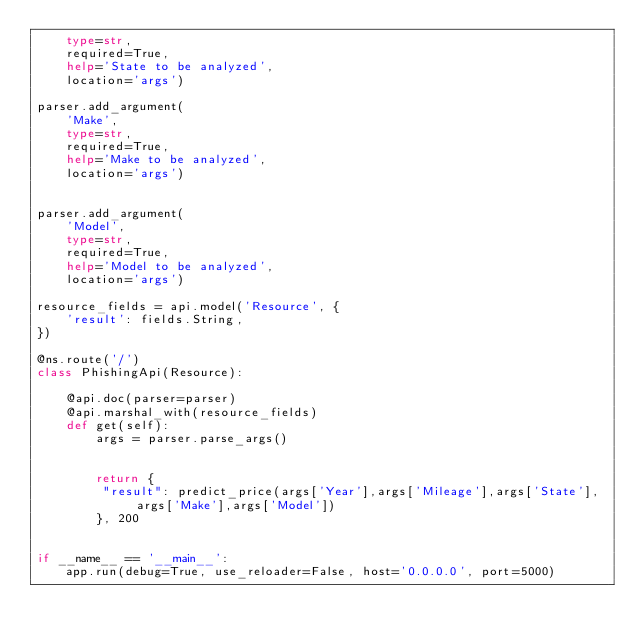Convert code to text. <code><loc_0><loc_0><loc_500><loc_500><_Python_>    type=str, 
    required=True, 
    help='State to be analyzed', 
    location='args')

parser.add_argument(
    'Make', 
    type=str, 
    required=True, 
    help='Make to be analyzed', 
    location='args')


parser.add_argument(
    'Model', 
    type=str, 
    required=True, 
    help='Model to be analyzed', 
    location='args')

resource_fields = api.model('Resource', {
    'result': fields.String,
})

@ns.route('/')
class PhishingApi(Resource):

    @api.doc(parser=parser)
    @api.marshal_with(resource_fields)
    def get(self):
        args = parser.parse_args()
        
                
        return {
         "result": predict_price(args['Year'],args['Mileage'],args['State'],args['Make'],args['Model'])
        }, 200
    
    
if __name__ == '__main__':
    app.run(debug=True, use_reloader=False, host='0.0.0.0', port=5000)
</code> 